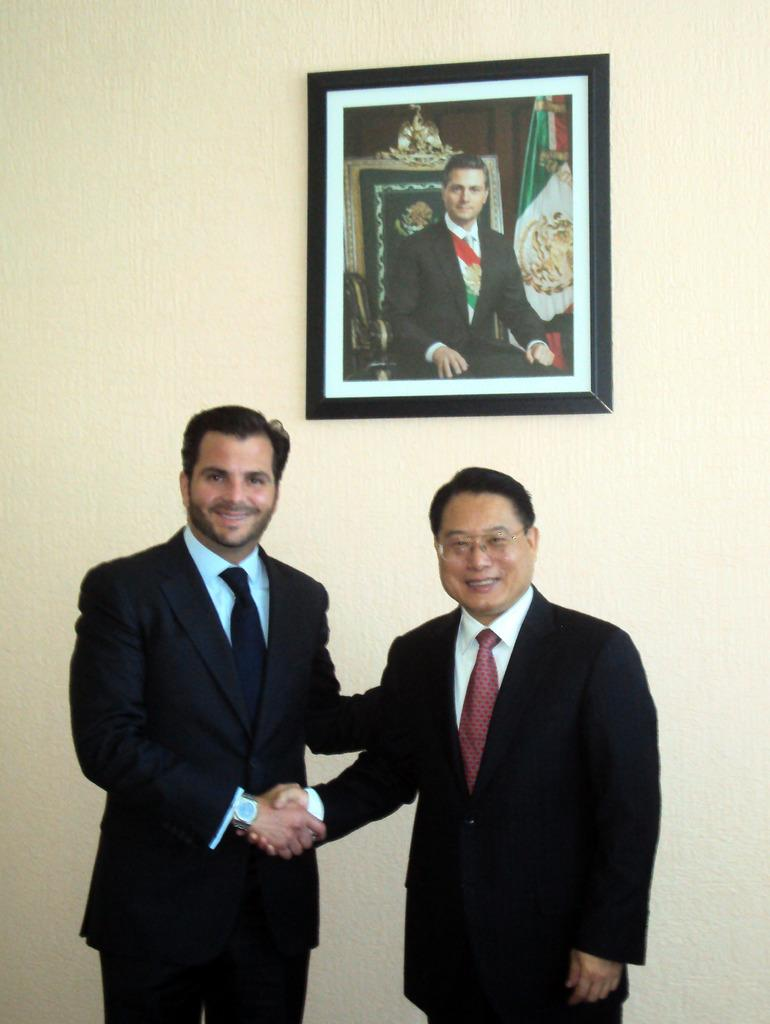How many people are in the image? There are two persons in the image. What are the two persons doing? The two persons are shaking hands. What can be seen in the background of the image? There is a wall in the background of the image. Is there anything on the wall in the image? Yes, there is a photo frame on the wall. What type of ticket is being distributed in the image? There is no ticket or distribution activity present in the image. 